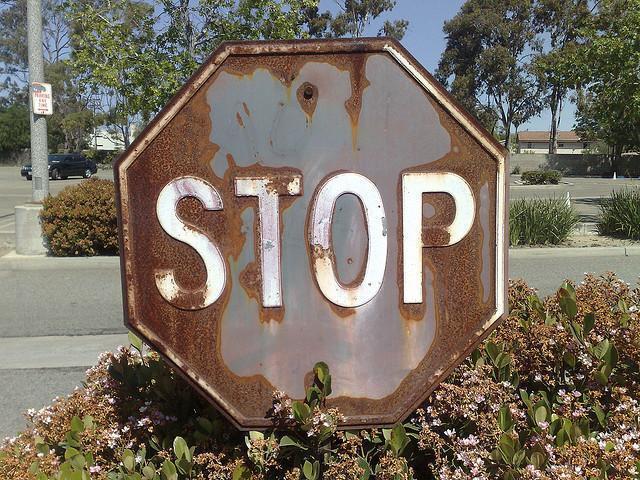How many elephants are shown?
Give a very brief answer. 0. 